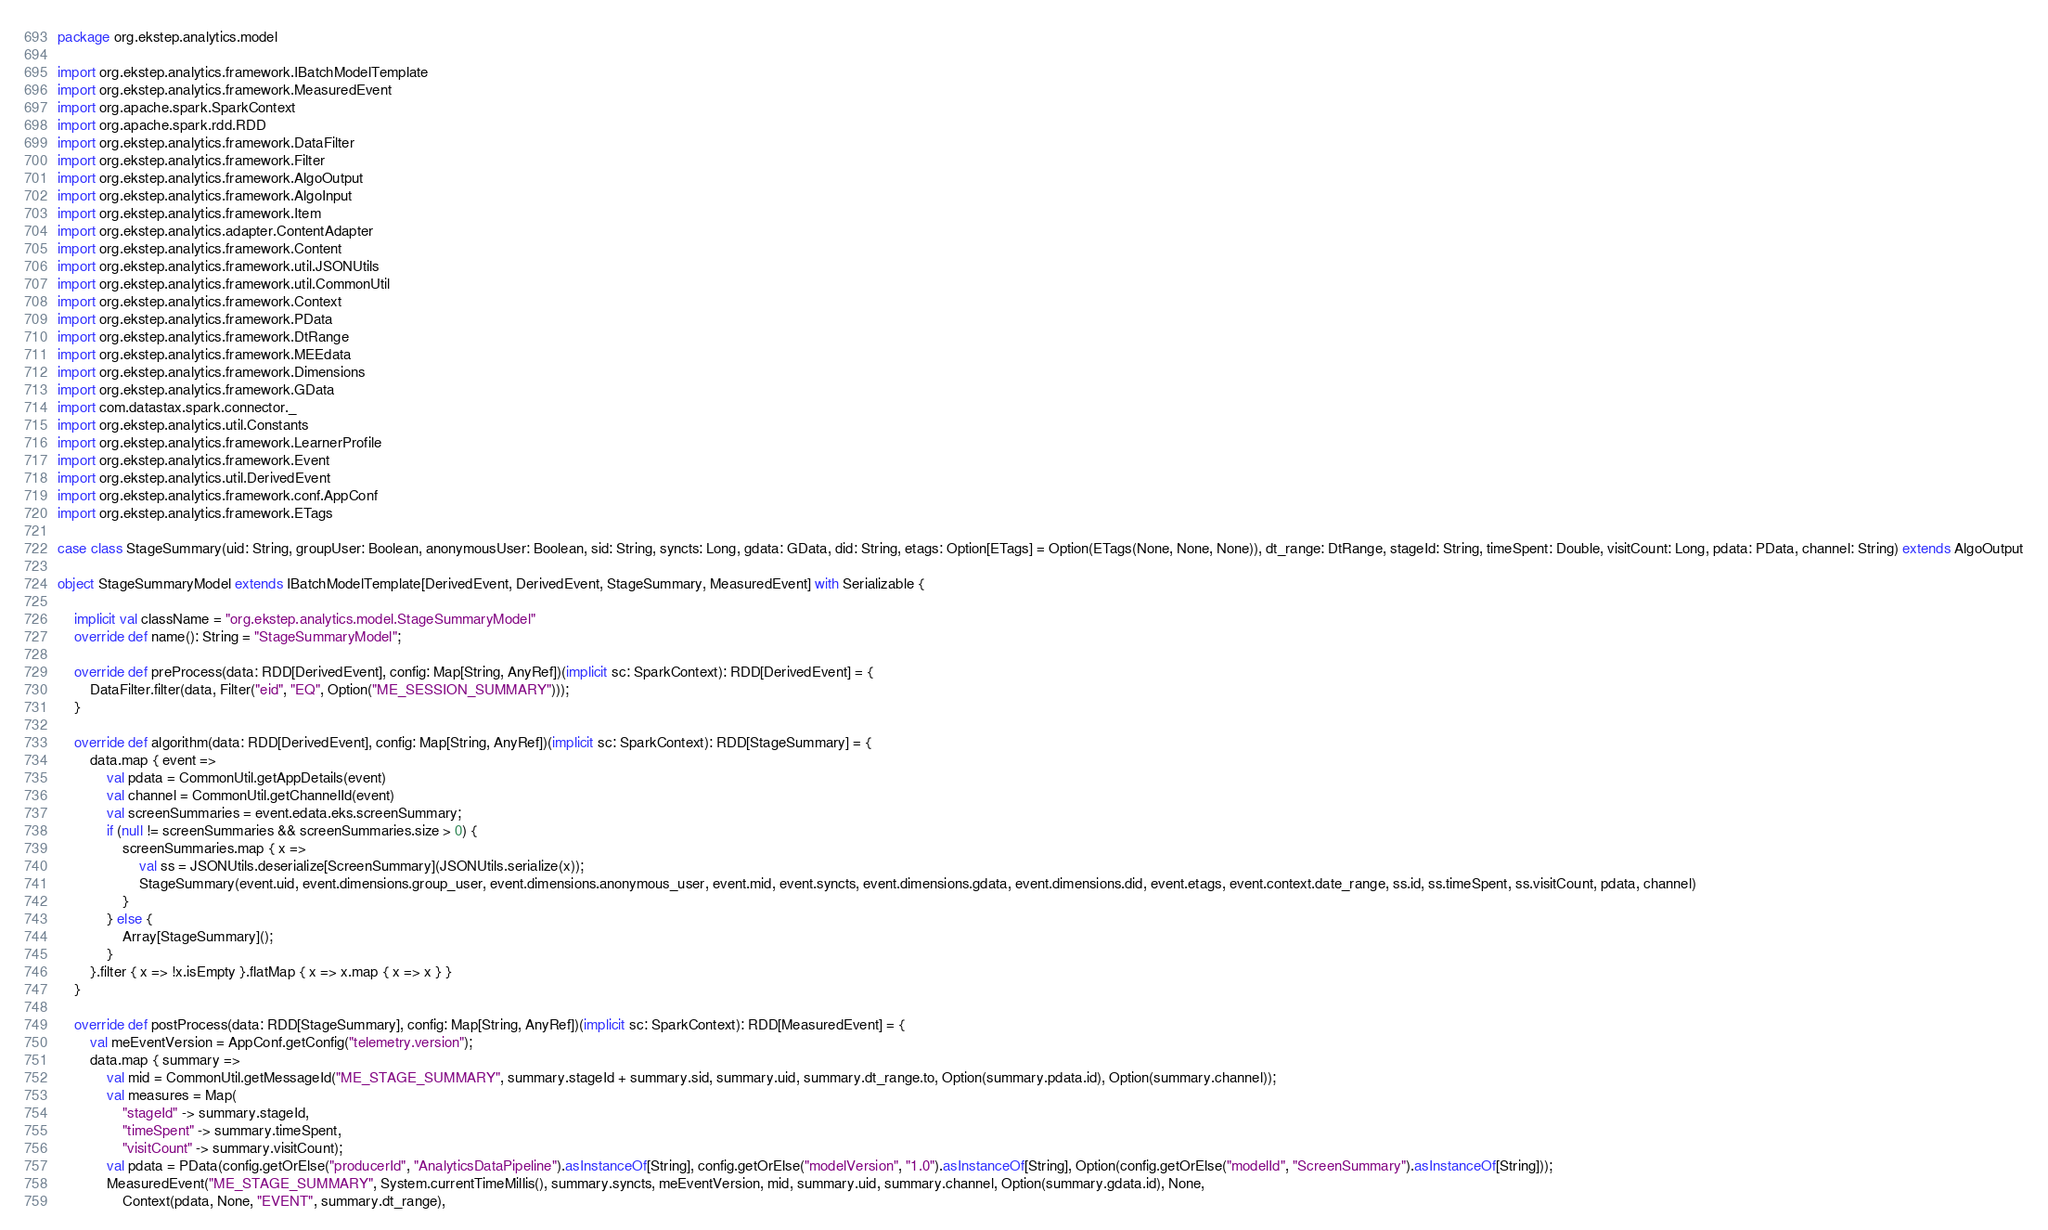<code> <loc_0><loc_0><loc_500><loc_500><_Scala_>package org.ekstep.analytics.model

import org.ekstep.analytics.framework.IBatchModelTemplate
import org.ekstep.analytics.framework.MeasuredEvent
import org.apache.spark.SparkContext
import org.apache.spark.rdd.RDD
import org.ekstep.analytics.framework.DataFilter
import org.ekstep.analytics.framework.Filter
import org.ekstep.analytics.framework.AlgoOutput
import org.ekstep.analytics.framework.AlgoInput
import org.ekstep.analytics.framework.Item
import org.ekstep.analytics.adapter.ContentAdapter
import org.ekstep.analytics.framework.Content
import org.ekstep.analytics.framework.util.JSONUtils
import org.ekstep.analytics.framework.util.CommonUtil
import org.ekstep.analytics.framework.Context
import org.ekstep.analytics.framework.PData
import org.ekstep.analytics.framework.DtRange
import org.ekstep.analytics.framework.MEEdata
import org.ekstep.analytics.framework.Dimensions
import org.ekstep.analytics.framework.GData
import com.datastax.spark.connector._
import org.ekstep.analytics.util.Constants
import org.ekstep.analytics.framework.LearnerProfile
import org.ekstep.analytics.framework.Event
import org.ekstep.analytics.util.DerivedEvent
import org.ekstep.analytics.framework.conf.AppConf
import org.ekstep.analytics.framework.ETags

case class StageSummary(uid: String, groupUser: Boolean, anonymousUser: Boolean, sid: String, syncts: Long, gdata: GData, did: String, etags: Option[ETags] = Option(ETags(None, None, None)), dt_range: DtRange, stageId: String, timeSpent: Double, visitCount: Long, pdata: PData, channel: String) extends AlgoOutput

object StageSummaryModel extends IBatchModelTemplate[DerivedEvent, DerivedEvent, StageSummary, MeasuredEvent] with Serializable {

    implicit val className = "org.ekstep.analytics.model.StageSummaryModel"
    override def name(): String = "StageSummaryModel";

    override def preProcess(data: RDD[DerivedEvent], config: Map[String, AnyRef])(implicit sc: SparkContext): RDD[DerivedEvent] = {
        DataFilter.filter(data, Filter("eid", "EQ", Option("ME_SESSION_SUMMARY")));
    }

    override def algorithm(data: RDD[DerivedEvent], config: Map[String, AnyRef])(implicit sc: SparkContext): RDD[StageSummary] = {
        data.map { event =>
            val pdata = CommonUtil.getAppDetails(event)
            val channel = CommonUtil.getChannelId(event)
            val screenSummaries = event.edata.eks.screenSummary;
            if (null != screenSummaries && screenSummaries.size > 0) {
                screenSummaries.map { x =>
                    val ss = JSONUtils.deserialize[ScreenSummary](JSONUtils.serialize(x));
                    StageSummary(event.uid, event.dimensions.group_user, event.dimensions.anonymous_user, event.mid, event.syncts, event.dimensions.gdata, event.dimensions.did, event.etags, event.context.date_range, ss.id, ss.timeSpent, ss.visitCount, pdata, channel)
                }
            } else {
                Array[StageSummary]();
            }
        }.filter { x => !x.isEmpty }.flatMap { x => x.map { x => x } }
    }

    override def postProcess(data: RDD[StageSummary], config: Map[String, AnyRef])(implicit sc: SparkContext): RDD[MeasuredEvent] = {
        val meEventVersion = AppConf.getConfig("telemetry.version");
        data.map { summary =>
            val mid = CommonUtil.getMessageId("ME_STAGE_SUMMARY", summary.stageId + summary.sid, summary.uid, summary.dt_range.to, Option(summary.pdata.id), Option(summary.channel));
            val measures = Map(
                "stageId" -> summary.stageId,
                "timeSpent" -> summary.timeSpent,
                "visitCount" -> summary.visitCount);
            val pdata = PData(config.getOrElse("producerId", "AnalyticsDataPipeline").asInstanceOf[String], config.getOrElse("modelVersion", "1.0").asInstanceOf[String], Option(config.getOrElse("modelId", "ScreenSummary").asInstanceOf[String]));
            MeasuredEvent("ME_STAGE_SUMMARY", System.currentTimeMillis(), summary.syncts, meEventVersion, mid, summary.uid, summary.channel, Option(summary.gdata.id), None,
                Context(pdata, None, "EVENT", summary.dt_range),</code> 